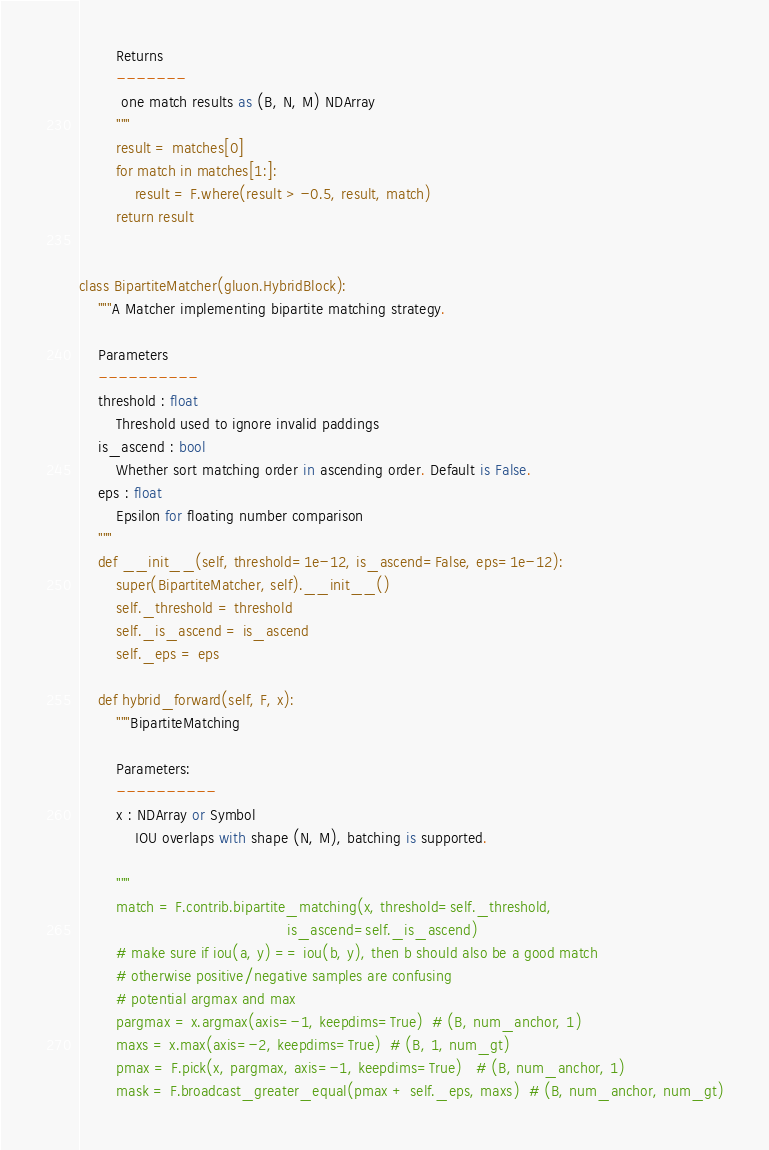<code> <loc_0><loc_0><loc_500><loc_500><_Python_>
        Returns
        -------
         one match results as (B, N, M) NDArray
        """
        result = matches[0]
        for match in matches[1:]:
            result = F.where(result > -0.5, result, match)
        return result


class BipartiteMatcher(gluon.HybridBlock):
    """A Matcher implementing bipartite matching strategy.

    Parameters
    ----------
    threshold : float
        Threshold used to ignore invalid paddings
    is_ascend : bool
        Whether sort matching order in ascending order. Default is False.
    eps : float
        Epsilon for floating number comparison
    """
    def __init__(self, threshold=1e-12, is_ascend=False, eps=1e-12):
        super(BipartiteMatcher, self).__init__()
        self._threshold = threshold
        self._is_ascend = is_ascend
        self._eps = eps

    def hybrid_forward(self, F, x):
        """BipartiteMatching

        Parameters:
        ----------
        x : NDArray or Symbol
            IOU overlaps with shape (N, M), batching is supported.

        """
        match = F.contrib.bipartite_matching(x, threshold=self._threshold,
                                             is_ascend=self._is_ascend)
        # make sure if iou(a, y) == iou(b, y), then b should also be a good match
        # otherwise positive/negative samples are confusing
        # potential argmax and max
        pargmax = x.argmax(axis=-1, keepdims=True)  # (B, num_anchor, 1)
        maxs = x.max(axis=-2, keepdims=True)  # (B, 1, num_gt)
        pmax = F.pick(x, pargmax, axis=-1, keepdims=True)   # (B, num_anchor, 1)
        mask = F.broadcast_greater_equal(pmax + self._eps, maxs)  # (B, num_anchor, num_gt)</code> 